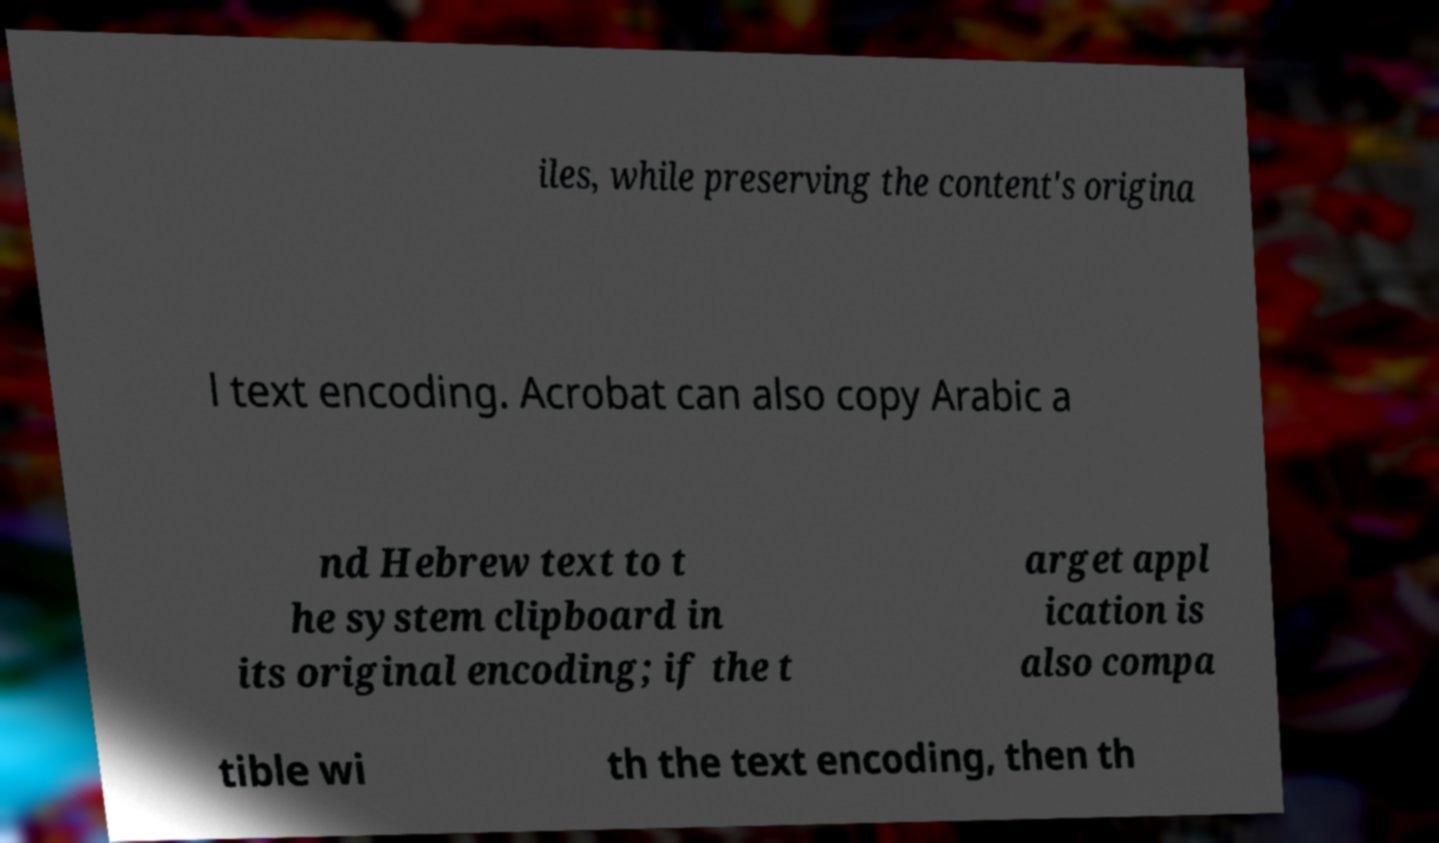I need the written content from this picture converted into text. Can you do that? iles, while preserving the content's origina l text encoding. Acrobat can also copy Arabic a nd Hebrew text to t he system clipboard in its original encoding; if the t arget appl ication is also compa tible wi th the text encoding, then th 